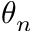<formula> <loc_0><loc_0><loc_500><loc_500>\theta _ { n }</formula> 